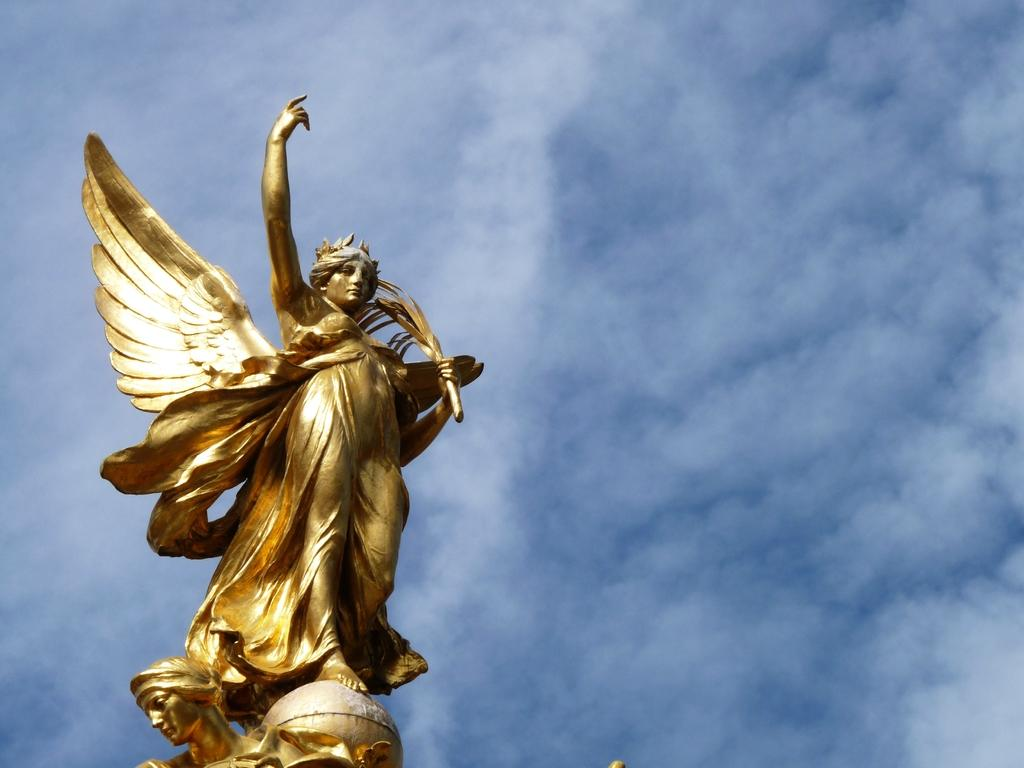What is the main subject of the image? The main subject of the image is a statue of a woman. What specific features does the statue have? The statue has wings and is gold in color. What can be seen in the background of the image? There is a sky visible in the background of the image. What is the condition of the sky in the image? Clouds are present in the sky. How many cars are parked near the statue in the image? There are no cars present in the image; it features a statue of a woman with wings and a gold color. What type of arm is visible on the statue in the image? The statue does not have an arm; it has wings instead. 